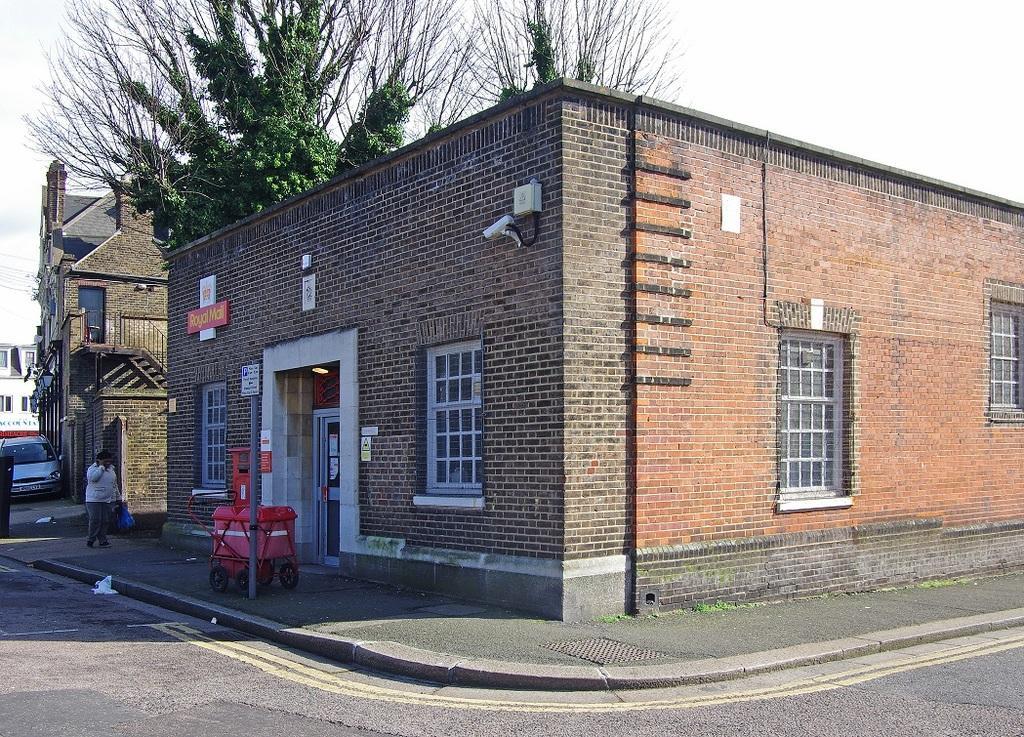How would you summarize this image in a sentence or two? In this image in front there is a road. There are buildings. There is a car. There is a person walking on the pavement. There is a pole. In the background of the image there are trees and sky. 